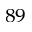Convert formula to latex. <formula><loc_0><loc_0><loc_500><loc_500>^ { 8 9 }</formula> 